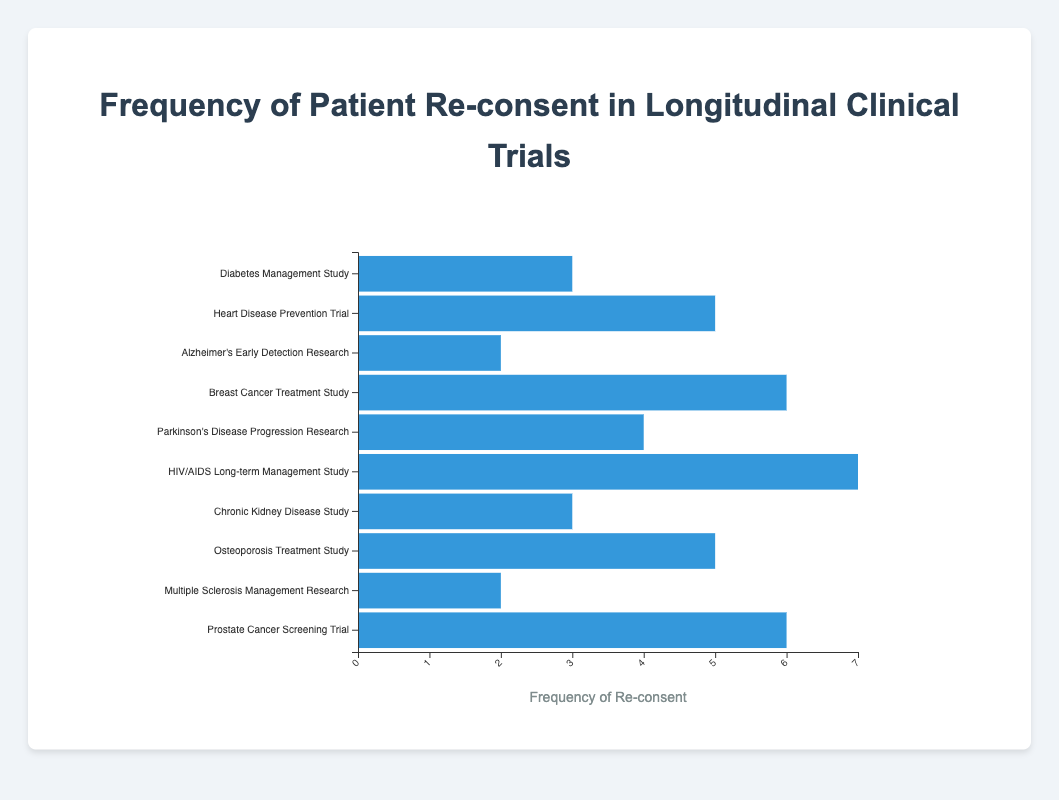Which study has the highest frequency of re-consent? By inspecting the length of the bars, the "HIV/AIDS Long-term Management Study" from the University of California, San Francisco has the highest bar, indicating the maximum frequency of re-consent.
Answer: HIV/AIDS Long-term Management Study Which studies have a frequency of re-consent greater than five? The visual lengths of the bars corresponding to the "HIV/AIDS Long-term Management Study" and "Breast Cancer Treatment Study" noticeably extend past the five-mark on the x-axis.
Answer: HIV/AIDS Long-term Management Study and Breast Cancer Treatment Study What is the trial duration for the study with the lowest frequency of re-consent? The "Alzheimer's Early Detection Research" and "Multiple Sclerosis Management Research" both have bars representing the lowest frequency of re-consent (2), with respective trial durations of 18 months and 54 months.
Answer: 18 months, 54 months Which institution has conducted the study with the longest trial duration? The longest trial duration, indicated by the study at the bottom of the chart, is 60 months for the "Prostate Cancer Screening Trial" conducted by the University of Texas MD Anderson Cancer Center.
Answer: University of Texas MD Anderson Cancer Center What is the total frequency of re-consent for all studies conducted by institutions on the east coast of the US? Identify studies conducted by Johns Hopkins University, Massachusetts General Hospital, Cleveland Clinic, University of Pittsburgh, and Duke University. Sum their frequencies, which are 3, 2, 6, 5, and 2, respectively. So, the total is 3 + 2 + 6 + 5 + 2 = 18.
Answer: 18 Which studies have a frequency of re-consent exactly equal to 3? The horizontal bars for "Diabetes Management Study" at Johns Hopkins University and "Chronic Kidney Disease Study" at the University of Michigan align perfectly with the 3-mark on the x-axis.
Answer: Diabetes Management Study and Chronic Kidney Disease Study Is there any study that has a 2 times higher frequency of re-consent compared to "Parkinson's Disease Progression Research"? The "Parkinson's Disease Progression Research" has a frequency of 4. A bar with double this value (8) does not appear in the chart, thus no study meets this criterion.
Answer: No 